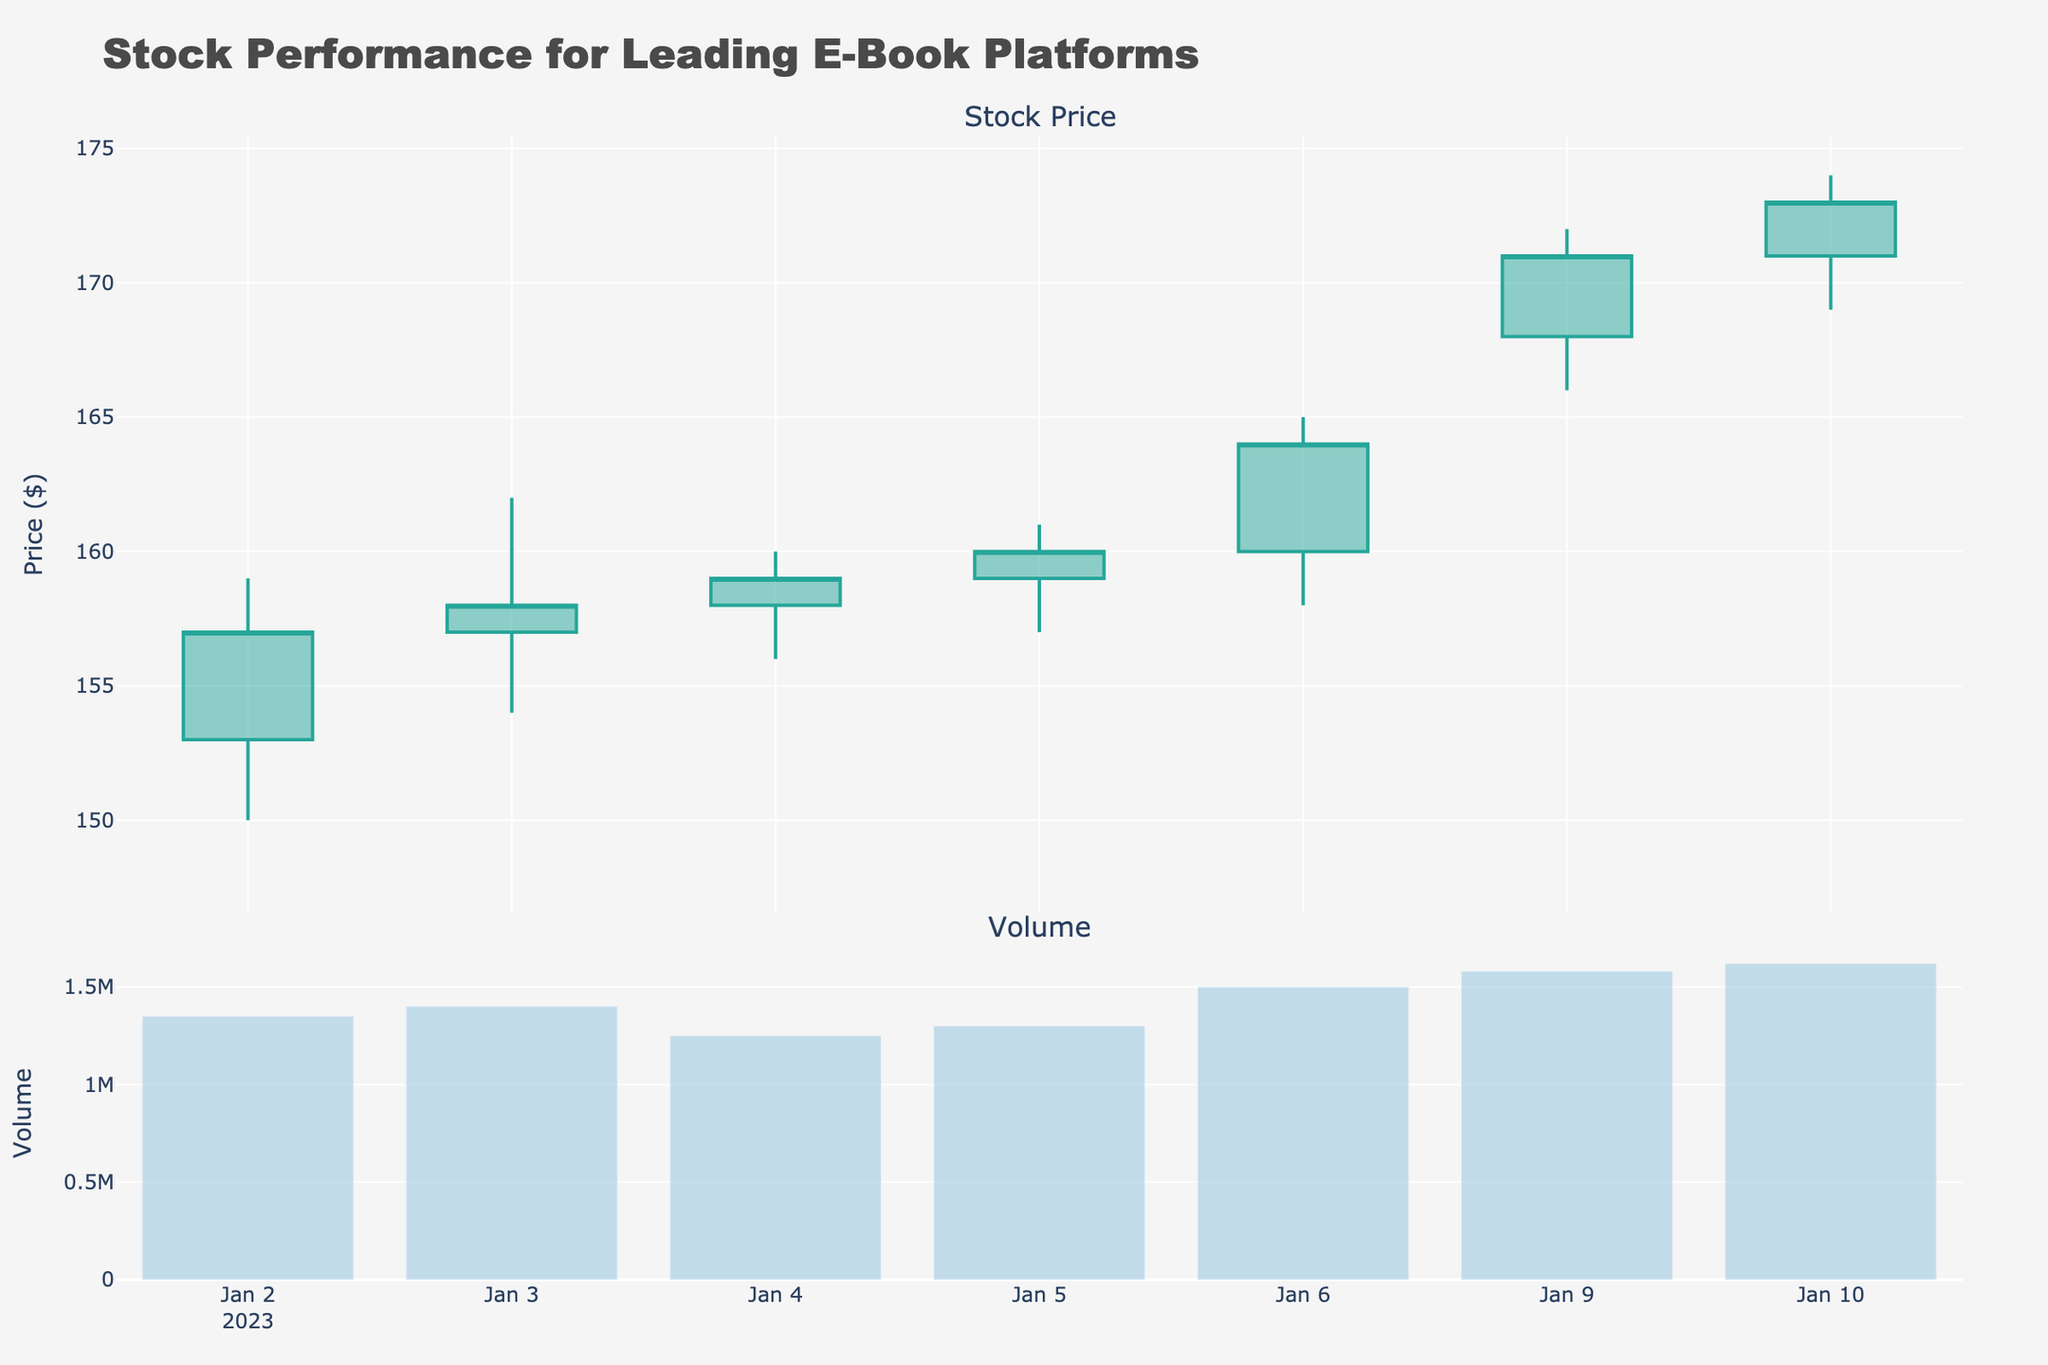What is the title of the figure? The title is displayed prominently at the top of the figure, which reads "Stock Performance for Leading E-Book Platforms".
Answer: Stock Performance for Leading E-Book Platforms What does the y-axis represent in the top subplot? The y-axis in the top subplot indicates the price of the stock in dollars, labeled as "Price ($)".
Answer: Price ($) How does the volume on January 10 compare to January 7? By examining the height of the bar for each date in the second subplot, we can see that January 10 has a higher volume bar than January 7.
Answer: January 10 has higher volume Over which dates does the candlestick chart span? The x-axis of the top subplot shows dates from January 1 to January 10, reflecting the time period of the stock performance data.
Answer: January 1 to January 10 How many days does the volume exceed 1.5 million shares? By counting the bars in the second subplot that surpass approximate mid-point between 1 to 2 million on the y-axis, we see this occurs on January 6, 7, 9, and 10.
Answer: 4 days Which day has the highest stock price? By examining the candlesticks, the highest price can be seen on January 7, with the stock's high point touching 170.
Answer: January 7 What is the price range on January 6? For January 6, the candlestick shows the lowest price at 158 and the highest at 165. The range is the difference between these values: 165 - 158 = 7.
Answer: 7 What was the closing price on January 3? The closing price for each date is illustrated by the top or bottom horizontal line of each candlestick. For January 3, it ends at 158.
Answer: 158 Which day shows the highest increase from open to close price? By calculating the difference between the open and close price for each day, we see January 7 (open at 164, close at 169) has the highest increase (169 - 164 = 5).
Answer: January 7 